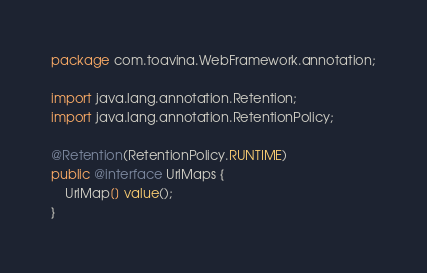<code> <loc_0><loc_0><loc_500><loc_500><_Java_>package com.toavina.WebFramework.annotation;

import java.lang.annotation.Retention;
import java.lang.annotation.RetentionPolicy;

@Retention(RetentionPolicy.RUNTIME)
public @interface UrlMaps {
    UrlMap[] value();
}

</code> 